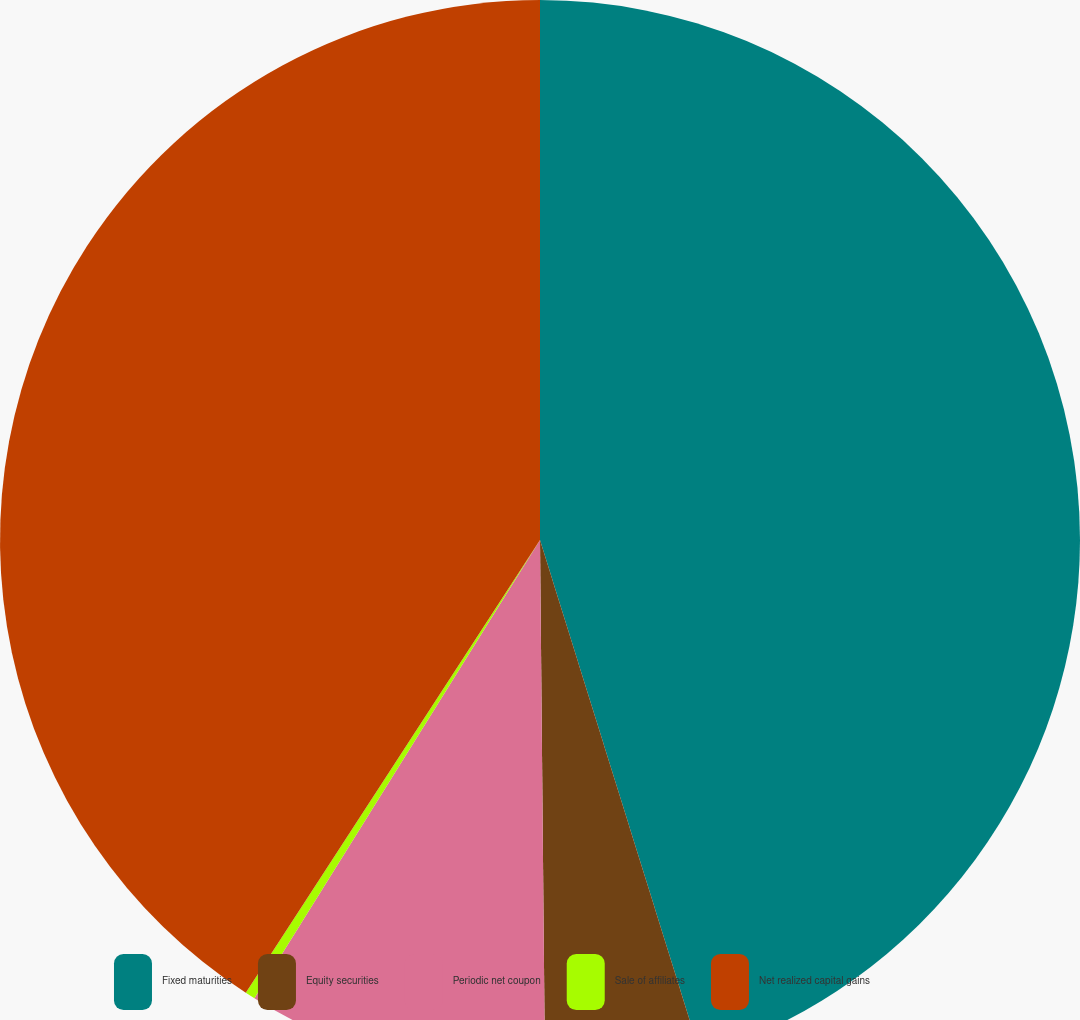Convert chart to OTSL. <chart><loc_0><loc_0><loc_500><loc_500><pie_chart><fcel>Fixed maturities<fcel>Equity securities<fcel>Periodic net coupon<fcel>Sale of affiliates<fcel>Net realized capital gains<nl><fcel>45.19%<fcel>4.66%<fcel>9.02%<fcel>0.3%<fcel>40.83%<nl></chart> 